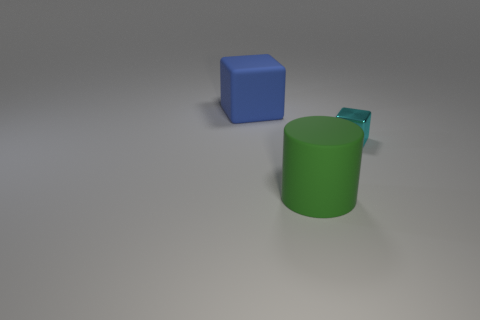Is the size of the object to the right of the matte cylinder the same as the large green thing?
Your answer should be compact. No. Are there any other things that have the same size as the green cylinder?
Offer a very short reply. Yes. Are there more small cubes to the left of the blue thing than small cyan shiny things that are in front of the tiny thing?
Keep it short and to the point. No. There is a big matte thing that is in front of the cube to the left of the cube that is to the right of the large rubber cylinder; what is its color?
Your answer should be very brief. Green. Does the large object in front of the cyan shiny thing have the same color as the big matte cube?
Offer a terse response. No. How many other things are the same color as the tiny object?
Make the answer very short. 0. What number of objects are blue matte blocks or large purple metal cubes?
Provide a succinct answer. 1. What number of objects are either large things or things that are in front of the metallic thing?
Your answer should be very brief. 2. Are the tiny cyan object and the blue object made of the same material?
Your answer should be very brief. No. How many other things are there of the same material as the blue block?
Provide a succinct answer. 1. 